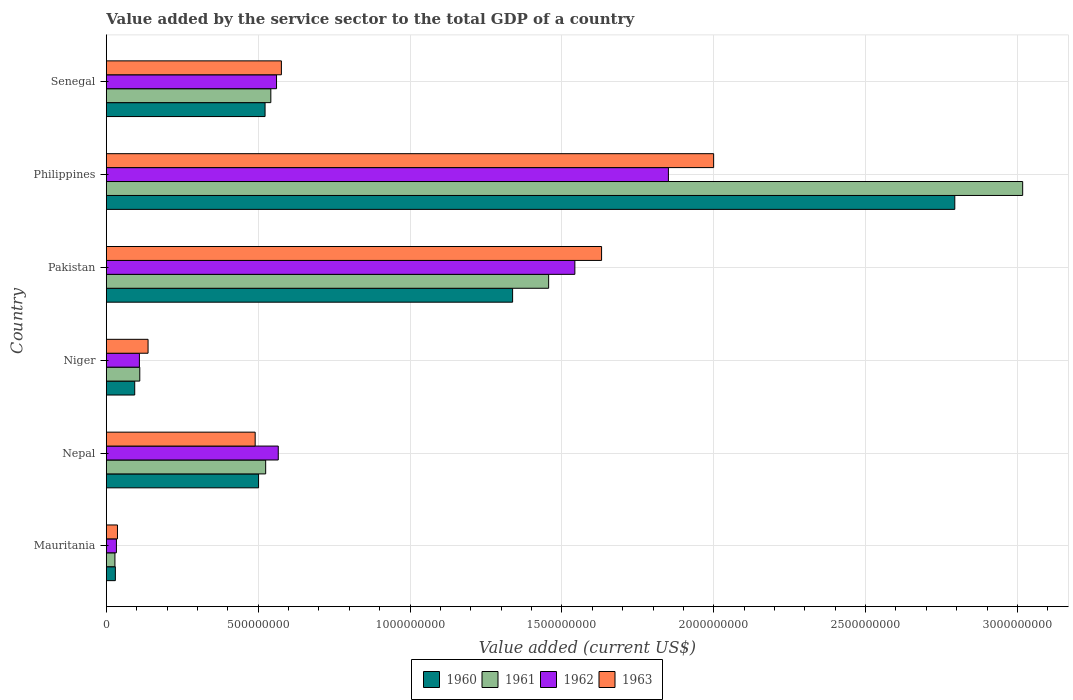How many groups of bars are there?
Provide a short and direct response. 6. Are the number of bars per tick equal to the number of legend labels?
Offer a very short reply. Yes. How many bars are there on the 2nd tick from the top?
Make the answer very short. 4. How many bars are there on the 4th tick from the bottom?
Your answer should be compact. 4. What is the value added by the service sector to the total GDP in 1960 in Mauritania?
Your response must be concise. 2.97e+07. Across all countries, what is the maximum value added by the service sector to the total GDP in 1962?
Keep it short and to the point. 1.85e+09. Across all countries, what is the minimum value added by the service sector to the total GDP in 1962?
Provide a succinct answer. 3.32e+07. In which country was the value added by the service sector to the total GDP in 1962 minimum?
Offer a terse response. Mauritania. What is the total value added by the service sector to the total GDP in 1960 in the graph?
Offer a terse response. 5.28e+09. What is the difference between the value added by the service sector to the total GDP in 1963 in Pakistan and that in Philippines?
Make the answer very short. -3.69e+08. What is the difference between the value added by the service sector to the total GDP in 1962 in Senegal and the value added by the service sector to the total GDP in 1960 in Philippines?
Provide a short and direct response. -2.23e+09. What is the average value added by the service sector to the total GDP in 1963 per country?
Make the answer very short. 8.12e+08. What is the difference between the value added by the service sector to the total GDP in 1960 and value added by the service sector to the total GDP in 1963 in Philippines?
Provide a short and direct response. 7.94e+08. In how many countries, is the value added by the service sector to the total GDP in 1960 greater than 1500000000 US$?
Ensure brevity in your answer.  1. What is the ratio of the value added by the service sector to the total GDP in 1963 in Niger to that in Pakistan?
Provide a succinct answer. 0.08. Is the value added by the service sector to the total GDP in 1963 in Mauritania less than that in Nepal?
Make the answer very short. Yes. What is the difference between the highest and the second highest value added by the service sector to the total GDP in 1960?
Provide a succinct answer. 1.46e+09. What is the difference between the highest and the lowest value added by the service sector to the total GDP in 1960?
Ensure brevity in your answer.  2.76e+09. In how many countries, is the value added by the service sector to the total GDP in 1963 greater than the average value added by the service sector to the total GDP in 1963 taken over all countries?
Keep it short and to the point. 2. Is it the case that in every country, the sum of the value added by the service sector to the total GDP in 1961 and value added by the service sector to the total GDP in 1960 is greater than the sum of value added by the service sector to the total GDP in 1963 and value added by the service sector to the total GDP in 1962?
Make the answer very short. No. What does the 2nd bar from the bottom in Pakistan represents?
Offer a terse response. 1961. How many countries are there in the graph?
Keep it short and to the point. 6. Are the values on the major ticks of X-axis written in scientific E-notation?
Ensure brevity in your answer.  No. Does the graph contain any zero values?
Offer a terse response. No. Does the graph contain grids?
Provide a short and direct response. Yes. How many legend labels are there?
Ensure brevity in your answer.  4. How are the legend labels stacked?
Your answer should be very brief. Horizontal. What is the title of the graph?
Provide a succinct answer. Value added by the service sector to the total GDP of a country. What is the label or title of the X-axis?
Give a very brief answer. Value added (current US$). What is the Value added (current US$) of 1960 in Mauritania?
Your response must be concise. 2.97e+07. What is the Value added (current US$) of 1961 in Mauritania?
Your answer should be very brief. 2.83e+07. What is the Value added (current US$) of 1962 in Mauritania?
Provide a succinct answer. 3.32e+07. What is the Value added (current US$) of 1963 in Mauritania?
Give a very brief answer. 3.67e+07. What is the Value added (current US$) of 1960 in Nepal?
Provide a short and direct response. 5.01e+08. What is the Value added (current US$) in 1961 in Nepal?
Provide a succinct answer. 5.25e+08. What is the Value added (current US$) of 1962 in Nepal?
Your response must be concise. 5.66e+08. What is the Value added (current US$) of 1963 in Nepal?
Your answer should be very brief. 4.90e+08. What is the Value added (current US$) in 1960 in Niger?
Make the answer very short. 9.35e+07. What is the Value added (current US$) of 1961 in Niger?
Offer a terse response. 1.10e+08. What is the Value added (current US$) of 1962 in Niger?
Provide a short and direct response. 1.09e+08. What is the Value added (current US$) in 1963 in Niger?
Provide a succinct answer. 1.37e+08. What is the Value added (current US$) of 1960 in Pakistan?
Provide a succinct answer. 1.34e+09. What is the Value added (current US$) in 1961 in Pakistan?
Ensure brevity in your answer.  1.46e+09. What is the Value added (current US$) of 1962 in Pakistan?
Your answer should be very brief. 1.54e+09. What is the Value added (current US$) in 1963 in Pakistan?
Give a very brief answer. 1.63e+09. What is the Value added (current US$) of 1960 in Philippines?
Ensure brevity in your answer.  2.79e+09. What is the Value added (current US$) in 1961 in Philippines?
Your answer should be compact. 3.02e+09. What is the Value added (current US$) of 1962 in Philippines?
Your answer should be compact. 1.85e+09. What is the Value added (current US$) in 1963 in Philippines?
Offer a very short reply. 2.00e+09. What is the Value added (current US$) of 1960 in Senegal?
Your answer should be compact. 5.23e+08. What is the Value added (current US$) of 1961 in Senegal?
Provide a short and direct response. 5.42e+08. What is the Value added (current US$) of 1962 in Senegal?
Your response must be concise. 5.60e+08. What is the Value added (current US$) in 1963 in Senegal?
Your response must be concise. 5.76e+08. Across all countries, what is the maximum Value added (current US$) in 1960?
Your answer should be compact. 2.79e+09. Across all countries, what is the maximum Value added (current US$) in 1961?
Your answer should be very brief. 3.02e+09. Across all countries, what is the maximum Value added (current US$) of 1962?
Provide a succinct answer. 1.85e+09. Across all countries, what is the maximum Value added (current US$) of 1963?
Provide a short and direct response. 2.00e+09. Across all countries, what is the minimum Value added (current US$) in 1960?
Your answer should be very brief. 2.97e+07. Across all countries, what is the minimum Value added (current US$) of 1961?
Provide a short and direct response. 2.83e+07. Across all countries, what is the minimum Value added (current US$) of 1962?
Your answer should be very brief. 3.32e+07. Across all countries, what is the minimum Value added (current US$) in 1963?
Make the answer very short. 3.67e+07. What is the total Value added (current US$) of 1960 in the graph?
Give a very brief answer. 5.28e+09. What is the total Value added (current US$) of 1961 in the graph?
Keep it short and to the point. 5.68e+09. What is the total Value added (current US$) of 1962 in the graph?
Ensure brevity in your answer.  4.66e+09. What is the total Value added (current US$) of 1963 in the graph?
Provide a succinct answer. 4.87e+09. What is the difference between the Value added (current US$) of 1960 in Mauritania and that in Nepal?
Your answer should be very brief. -4.72e+08. What is the difference between the Value added (current US$) in 1961 in Mauritania and that in Nepal?
Your response must be concise. -4.96e+08. What is the difference between the Value added (current US$) in 1962 in Mauritania and that in Nepal?
Your answer should be compact. -5.33e+08. What is the difference between the Value added (current US$) in 1963 in Mauritania and that in Nepal?
Ensure brevity in your answer.  -4.53e+08. What is the difference between the Value added (current US$) of 1960 in Mauritania and that in Niger?
Provide a succinct answer. -6.37e+07. What is the difference between the Value added (current US$) of 1961 in Mauritania and that in Niger?
Your answer should be very brief. -8.18e+07. What is the difference between the Value added (current US$) in 1962 in Mauritania and that in Niger?
Your answer should be compact. -7.57e+07. What is the difference between the Value added (current US$) in 1963 in Mauritania and that in Niger?
Your answer should be very brief. -1.01e+08. What is the difference between the Value added (current US$) in 1960 in Mauritania and that in Pakistan?
Give a very brief answer. -1.31e+09. What is the difference between the Value added (current US$) in 1961 in Mauritania and that in Pakistan?
Your answer should be very brief. -1.43e+09. What is the difference between the Value added (current US$) in 1962 in Mauritania and that in Pakistan?
Ensure brevity in your answer.  -1.51e+09. What is the difference between the Value added (current US$) of 1963 in Mauritania and that in Pakistan?
Your answer should be compact. -1.59e+09. What is the difference between the Value added (current US$) of 1960 in Mauritania and that in Philippines?
Make the answer very short. -2.76e+09. What is the difference between the Value added (current US$) of 1961 in Mauritania and that in Philippines?
Your answer should be very brief. -2.99e+09. What is the difference between the Value added (current US$) of 1962 in Mauritania and that in Philippines?
Your answer should be very brief. -1.82e+09. What is the difference between the Value added (current US$) of 1963 in Mauritania and that in Philippines?
Offer a very short reply. -1.96e+09. What is the difference between the Value added (current US$) in 1960 in Mauritania and that in Senegal?
Ensure brevity in your answer.  -4.93e+08. What is the difference between the Value added (current US$) in 1961 in Mauritania and that in Senegal?
Ensure brevity in your answer.  -5.13e+08. What is the difference between the Value added (current US$) in 1962 in Mauritania and that in Senegal?
Offer a terse response. -5.27e+08. What is the difference between the Value added (current US$) in 1963 in Mauritania and that in Senegal?
Ensure brevity in your answer.  -5.40e+08. What is the difference between the Value added (current US$) of 1960 in Nepal and that in Niger?
Ensure brevity in your answer.  4.08e+08. What is the difference between the Value added (current US$) of 1961 in Nepal and that in Niger?
Offer a terse response. 4.14e+08. What is the difference between the Value added (current US$) of 1962 in Nepal and that in Niger?
Offer a terse response. 4.57e+08. What is the difference between the Value added (current US$) in 1963 in Nepal and that in Niger?
Keep it short and to the point. 3.53e+08. What is the difference between the Value added (current US$) of 1960 in Nepal and that in Pakistan?
Offer a terse response. -8.36e+08. What is the difference between the Value added (current US$) of 1961 in Nepal and that in Pakistan?
Provide a succinct answer. -9.32e+08. What is the difference between the Value added (current US$) of 1962 in Nepal and that in Pakistan?
Provide a succinct answer. -9.77e+08. What is the difference between the Value added (current US$) of 1963 in Nepal and that in Pakistan?
Offer a very short reply. -1.14e+09. What is the difference between the Value added (current US$) in 1960 in Nepal and that in Philippines?
Your answer should be very brief. -2.29e+09. What is the difference between the Value added (current US$) of 1961 in Nepal and that in Philippines?
Provide a short and direct response. -2.49e+09. What is the difference between the Value added (current US$) in 1962 in Nepal and that in Philippines?
Give a very brief answer. -1.28e+09. What is the difference between the Value added (current US$) in 1963 in Nepal and that in Philippines?
Give a very brief answer. -1.51e+09. What is the difference between the Value added (current US$) in 1960 in Nepal and that in Senegal?
Keep it short and to the point. -2.14e+07. What is the difference between the Value added (current US$) in 1961 in Nepal and that in Senegal?
Your answer should be compact. -1.70e+07. What is the difference between the Value added (current US$) of 1962 in Nepal and that in Senegal?
Give a very brief answer. 5.71e+06. What is the difference between the Value added (current US$) of 1963 in Nepal and that in Senegal?
Give a very brief answer. -8.63e+07. What is the difference between the Value added (current US$) of 1960 in Niger and that in Pakistan?
Ensure brevity in your answer.  -1.24e+09. What is the difference between the Value added (current US$) of 1961 in Niger and that in Pakistan?
Keep it short and to the point. -1.35e+09. What is the difference between the Value added (current US$) of 1962 in Niger and that in Pakistan?
Provide a short and direct response. -1.43e+09. What is the difference between the Value added (current US$) in 1963 in Niger and that in Pakistan?
Your answer should be very brief. -1.49e+09. What is the difference between the Value added (current US$) in 1960 in Niger and that in Philippines?
Ensure brevity in your answer.  -2.70e+09. What is the difference between the Value added (current US$) of 1961 in Niger and that in Philippines?
Ensure brevity in your answer.  -2.91e+09. What is the difference between the Value added (current US$) in 1962 in Niger and that in Philippines?
Give a very brief answer. -1.74e+09. What is the difference between the Value added (current US$) of 1963 in Niger and that in Philippines?
Provide a succinct answer. -1.86e+09. What is the difference between the Value added (current US$) of 1960 in Niger and that in Senegal?
Give a very brief answer. -4.29e+08. What is the difference between the Value added (current US$) of 1961 in Niger and that in Senegal?
Offer a terse response. -4.32e+08. What is the difference between the Value added (current US$) of 1962 in Niger and that in Senegal?
Ensure brevity in your answer.  -4.51e+08. What is the difference between the Value added (current US$) in 1963 in Niger and that in Senegal?
Offer a terse response. -4.39e+08. What is the difference between the Value added (current US$) in 1960 in Pakistan and that in Philippines?
Your response must be concise. -1.46e+09. What is the difference between the Value added (current US$) of 1961 in Pakistan and that in Philippines?
Your response must be concise. -1.56e+09. What is the difference between the Value added (current US$) of 1962 in Pakistan and that in Philippines?
Ensure brevity in your answer.  -3.08e+08. What is the difference between the Value added (current US$) of 1963 in Pakistan and that in Philippines?
Your answer should be compact. -3.69e+08. What is the difference between the Value added (current US$) in 1960 in Pakistan and that in Senegal?
Ensure brevity in your answer.  8.15e+08. What is the difference between the Value added (current US$) of 1961 in Pakistan and that in Senegal?
Make the answer very short. 9.15e+08. What is the difference between the Value added (current US$) of 1962 in Pakistan and that in Senegal?
Make the answer very short. 9.82e+08. What is the difference between the Value added (current US$) in 1963 in Pakistan and that in Senegal?
Your answer should be very brief. 1.05e+09. What is the difference between the Value added (current US$) of 1960 in Philippines and that in Senegal?
Provide a succinct answer. 2.27e+09. What is the difference between the Value added (current US$) of 1961 in Philippines and that in Senegal?
Give a very brief answer. 2.48e+09. What is the difference between the Value added (current US$) of 1962 in Philippines and that in Senegal?
Offer a very short reply. 1.29e+09. What is the difference between the Value added (current US$) in 1963 in Philippines and that in Senegal?
Provide a succinct answer. 1.42e+09. What is the difference between the Value added (current US$) of 1960 in Mauritania and the Value added (current US$) of 1961 in Nepal?
Give a very brief answer. -4.95e+08. What is the difference between the Value added (current US$) in 1960 in Mauritania and the Value added (current US$) in 1962 in Nepal?
Your answer should be compact. -5.36e+08. What is the difference between the Value added (current US$) in 1960 in Mauritania and the Value added (current US$) in 1963 in Nepal?
Provide a succinct answer. -4.60e+08. What is the difference between the Value added (current US$) of 1961 in Mauritania and the Value added (current US$) of 1962 in Nepal?
Provide a succinct answer. -5.38e+08. What is the difference between the Value added (current US$) in 1961 in Mauritania and the Value added (current US$) in 1963 in Nepal?
Your answer should be compact. -4.62e+08. What is the difference between the Value added (current US$) of 1962 in Mauritania and the Value added (current US$) of 1963 in Nepal?
Your response must be concise. -4.57e+08. What is the difference between the Value added (current US$) in 1960 in Mauritania and the Value added (current US$) in 1961 in Niger?
Ensure brevity in your answer.  -8.04e+07. What is the difference between the Value added (current US$) of 1960 in Mauritania and the Value added (current US$) of 1962 in Niger?
Provide a succinct answer. -7.92e+07. What is the difference between the Value added (current US$) in 1960 in Mauritania and the Value added (current US$) in 1963 in Niger?
Your answer should be compact. -1.08e+08. What is the difference between the Value added (current US$) of 1961 in Mauritania and the Value added (current US$) of 1962 in Niger?
Offer a very short reply. -8.06e+07. What is the difference between the Value added (current US$) in 1961 in Mauritania and the Value added (current US$) in 1963 in Niger?
Your response must be concise. -1.09e+08. What is the difference between the Value added (current US$) of 1962 in Mauritania and the Value added (current US$) of 1963 in Niger?
Your answer should be very brief. -1.04e+08. What is the difference between the Value added (current US$) in 1960 in Mauritania and the Value added (current US$) in 1961 in Pakistan?
Provide a succinct answer. -1.43e+09. What is the difference between the Value added (current US$) of 1960 in Mauritania and the Value added (current US$) of 1962 in Pakistan?
Ensure brevity in your answer.  -1.51e+09. What is the difference between the Value added (current US$) in 1960 in Mauritania and the Value added (current US$) in 1963 in Pakistan?
Offer a terse response. -1.60e+09. What is the difference between the Value added (current US$) in 1961 in Mauritania and the Value added (current US$) in 1962 in Pakistan?
Make the answer very short. -1.51e+09. What is the difference between the Value added (current US$) in 1961 in Mauritania and the Value added (current US$) in 1963 in Pakistan?
Offer a very short reply. -1.60e+09. What is the difference between the Value added (current US$) in 1962 in Mauritania and the Value added (current US$) in 1963 in Pakistan?
Provide a short and direct response. -1.60e+09. What is the difference between the Value added (current US$) in 1960 in Mauritania and the Value added (current US$) in 1961 in Philippines?
Your answer should be compact. -2.99e+09. What is the difference between the Value added (current US$) in 1960 in Mauritania and the Value added (current US$) in 1962 in Philippines?
Provide a succinct answer. -1.82e+09. What is the difference between the Value added (current US$) of 1960 in Mauritania and the Value added (current US$) of 1963 in Philippines?
Keep it short and to the point. -1.97e+09. What is the difference between the Value added (current US$) in 1961 in Mauritania and the Value added (current US$) in 1962 in Philippines?
Provide a succinct answer. -1.82e+09. What is the difference between the Value added (current US$) of 1961 in Mauritania and the Value added (current US$) of 1963 in Philippines?
Make the answer very short. -1.97e+09. What is the difference between the Value added (current US$) in 1962 in Mauritania and the Value added (current US$) in 1963 in Philippines?
Your response must be concise. -1.97e+09. What is the difference between the Value added (current US$) in 1960 in Mauritania and the Value added (current US$) in 1961 in Senegal?
Ensure brevity in your answer.  -5.12e+08. What is the difference between the Value added (current US$) of 1960 in Mauritania and the Value added (current US$) of 1962 in Senegal?
Your response must be concise. -5.31e+08. What is the difference between the Value added (current US$) of 1960 in Mauritania and the Value added (current US$) of 1963 in Senegal?
Your answer should be compact. -5.47e+08. What is the difference between the Value added (current US$) in 1961 in Mauritania and the Value added (current US$) in 1962 in Senegal?
Your response must be concise. -5.32e+08. What is the difference between the Value added (current US$) of 1961 in Mauritania and the Value added (current US$) of 1963 in Senegal?
Ensure brevity in your answer.  -5.48e+08. What is the difference between the Value added (current US$) in 1962 in Mauritania and the Value added (current US$) in 1963 in Senegal?
Give a very brief answer. -5.43e+08. What is the difference between the Value added (current US$) of 1960 in Nepal and the Value added (current US$) of 1961 in Niger?
Keep it short and to the point. 3.91e+08. What is the difference between the Value added (current US$) in 1960 in Nepal and the Value added (current US$) in 1962 in Niger?
Make the answer very short. 3.92e+08. What is the difference between the Value added (current US$) in 1960 in Nepal and the Value added (current US$) in 1963 in Niger?
Provide a short and direct response. 3.64e+08. What is the difference between the Value added (current US$) of 1961 in Nepal and the Value added (current US$) of 1962 in Niger?
Your response must be concise. 4.16e+08. What is the difference between the Value added (current US$) in 1961 in Nepal and the Value added (current US$) in 1963 in Niger?
Give a very brief answer. 3.87e+08. What is the difference between the Value added (current US$) in 1962 in Nepal and the Value added (current US$) in 1963 in Niger?
Your response must be concise. 4.29e+08. What is the difference between the Value added (current US$) of 1960 in Nepal and the Value added (current US$) of 1961 in Pakistan?
Provide a succinct answer. -9.55e+08. What is the difference between the Value added (current US$) in 1960 in Nepal and the Value added (current US$) in 1962 in Pakistan?
Make the answer very short. -1.04e+09. What is the difference between the Value added (current US$) in 1960 in Nepal and the Value added (current US$) in 1963 in Pakistan?
Provide a short and direct response. -1.13e+09. What is the difference between the Value added (current US$) in 1961 in Nepal and the Value added (current US$) in 1962 in Pakistan?
Your response must be concise. -1.02e+09. What is the difference between the Value added (current US$) of 1961 in Nepal and the Value added (current US$) of 1963 in Pakistan?
Provide a short and direct response. -1.11e+09. What is the difference between the Value added (current US$) in 1962 in Nepal and the Value added (current US$) in 1963 in Pakistan?
Give a very brief answer. -1.06e+09. What is the difference between the Value added (current US$) of 1960 in Nepal and the Value added (current US$) of 1961 in Philippines?
Provide a short and direct response. -2.52e+09. What is the difference between the Value added (current US$) of 1960 in Nepal and the Value added (current US$) of 1962 in Philippines?
Give a very brief answer. -1.35e+09. What is the difference between the Value added (current US$) in 1960 in Nepal and the Value added (current US$) in 1963 in Philippines?
Ensure brevity in your answer.  -1.50e+09. What is the difference between the Value added (current US$) of 1961 in Nepal and the Value added (current US$) of 1962 in Philippines?
Your answer should be compact. -1.33e+09. What is the difference between the Value added (current US$) in 1961 in Nepal and the Value added (current US$) in 1963 in Philippines?
Your answer should be very brief. -1.47e+09. What is the difference between the Value added (current US$) in 1962 in Nepal and the Value added (current US$) in 1963 in Philippines?
Provide a short and direct response. -1.43e+09. What is the difference between the Value added (current US$) of 1960 in Nepal and the Value added (current US$) of 1961 in Senegal?
Provide a succinct answer. -4.04e+07. What is the difference between the Value added (current US$) in 1960 in Nepal and the Value added (current US$) in 1962 in Senegal?
Give a very brief answer. -5.91e+07. What is the difference between the Value added (current US$) of 1960 in Nepal and the Value added (current US$) of 1963 in Senegal?
Your answer should be compact. -7.51e+07. What is the difference between the Value added (current US$) of 1961 in Nepal and the Value added (current US$) of 1962 in Senegal?
Your answer should be compact. -3.58e+07. What is the difference between the Value added (current US$) in 1961 in Nepal and the Value added (current US$) in 1963 in Senegal?
Offer a terse response. -5.18e+07. What is the difference between the Value added (current US$) in 1962 in Nepal and the Value added (current US$) in 1963 in Senegal?
Keep it short and to the point. -1.03e+07. What is the difference between the Value added (current US$) of 1960 in Niger and the Value added (current US$) of 1961 in Pakistan?
Make the answer very short. -1.36e+09. What is the difference between the Value added (current US$) of 1960 in Niger and the Value added (current US$) of 1962 in Pakistan?
Provide a short and direct response. -1.45e+09. What is the difference between the Value added (current US$) in 1960 in Niger and the Value added (current US$) in 1963 in Pakistan?
Provide a succinct answer. -1.54e+09. What is the difference between the Value added (current US$) of 1961 in Niger and the Value added (current US$) of 1962 in Pakistan?
Your response must be concise. -1.43e+09. What is the difference between the Value added (current US$) in 1961 in Niger and the Value added (current US$) in 1963 in Pakistan?
Provide a succinct answer. -1.52e+09. What is the difference between the Value added (current US$) in 1962 in Niger and the Value added (current US$) in 1963 in Pakistan?
Your answer should be compact. -1.52e+09. What is the difference between the Value added (current US$) of 1960 in Niger and the Value added (current US$) of 1961 in Philippines?
Provide a short and direct response. -2.92e+09. What is the difference between the Value added (current US$) of 1960 in Niger and the Value added (current US$) of 1962 in Philippines?
Keep it short and to the point. -1.76e+09. What is the difference between the Value added (current US$) of 1960 in Niger and the Value added (current US$) of 1963 in Philippines?
Give a very brief answer. -1.91e+09. What is the difference between the Value added (current US$) in 1961 in Niger and the Value added (current US$) in 1962 in Philippines?
Your answer should be very brief. -1.74e+09. What is the difference between the Value added (current US$) of 1961 in Niger and the Value added (current US$) of 1963 in Philippines?
Provide a short and direct response. -1.89e+09. What is the difference between the Value added (current US$) in 1962 in Niger and the Value added (current US$) in 1963 in Philippines?
Your response must be concise. -1.89e+09. What is the difference between the Value added (current US$) in 1960 in Niger and the Value added (current US$) in 1961 in Senegal?
Offer a very short reply. -4.48e+08. What is the difference between the Value added (current US$) of 1960 in Niger and the Value added (current US$) of 1962 in Senegal?
Ensure brevity in your answer.  -4.67e+08. What is the difference between the Value added (current US$) of 1960 in Niger and the Value added (current US$) of 1963 in Senegal?
Offer a very short reply. -4.83e+08. What is the difference between the Value added (current US$) in 1961 in Niger and the Value added (current US$) in 1962 in Senegal?
Offer a very short reply. -4.50e+08. What is the difference between the Value added (current US$) of 1961 in Niger and the Value added (current US$) of 1963 in Senegal?
Give a very brief answer. -4.66e+08. What is the difference between the Value added (current US$) in 1962 in Niger and the Value added (current US$) in 1963 in Senegal?
Provide a short and direct response. -4.67e+08. What is the difference between the Value added (current US$) in 1960 in Pakistan and the Value added (current US$) in 1961 in Philippines?
Ensure brevity in your answer.  -1.68e+09. What is the difference between the Value added (current US$) of 1960 in Pakistan and the Value added (current US$) of 1962 in Philippines?
Give a very brief answer. -5.13e+08. What is the difference between the Value added (current US$) of 1960 in Pakistan and the Value added (current US$) of 1963 in Philippines?
Offer a very short reply. -6.62e+08. What is the difference between the Value added (current US$) in 1961 in Pakistan and the Value added (current US$) in 1962 in Philippines?
Give a very brief answer. -3.94e+08. What is the difference between the Value added (current US$) in 1961 in Pakistan and the Value added (current US$) in 1963 in Philippines?
Make the answer very short. -5.43e+08. What is the difference between the Value added (current US$) in 1962 in Pakistan and the Value added (current US$) in 1963 in Philippines?
Give a very brief answer. -4.57e+08. What is the difference between the Value added (current US$) in 1960 in Pakistan and the Value added (current US$) in 1961 in Senegal?
Offer a terse response. 7.96e+08. What is the difference between the Value added (current US$) of 1960 in Pakistan and the Value added (current US$) of 1962 in Senegal?
Provide a succinct answer. 7.77e+08. What is the difference between the Value added (current US$) of 1960 in Pakistan and the Value added (current US$) of 1963 in Senegal?
Make the answer very short. 7.61e+08. What is the difference between the Value added (current US$) of 1961 in Pakistan and the Value added (current US$) of 1962 in Senegal?
Provide a short and direct response. 8.96e+08. What is the difference between the Value added (current US$) of 1961 in Pakistan and the Value added (current US$) of 1963 in Senegal?
Your response must be concise. 8.80e+08. What is the difference between the Value added (current US$) of 1962 in Pakistan and the Value added (current US$) of 1963 in Senegal?
Provide a succinct answer. 9.66e+08. What is the difference between the Value added (current US$) of 1960 in Philippines and the Value added (current US$) of 1961 in Senegal?
Offer a terse response. 2.25e+09. What is the difference between the Value added (current US$) of 1960 in Philippines and the Value added (current US$) of 1962 in Senegal?
Ensure brevity in your answer.  2.23e+09. What is the difference between the Value added (current US$) in 1960 in Philippines and the Value added (current US$) in 1963 in Senegal?
Your response must be concise. 2.22e+09. What is the difference between the Value added (current US$) of 1961 in Philippines and the Value added (current US$) of 1962 in Senegal?
Offer a terse response. 2.46e+09. What is the difference between the Value added (current US$) of 1961 in Philippines and the Value added (current US$) of 1963 in Senegal?
Offer a terse response. 2.44e+09. What is the difference between the Value added (current US$) of 1962 in Philippines and the Value added (current US$) of 1963 in Senegal?
Offer a very short reply. 1.27e+09. What is the average Value added (current US$) of 1960 per country?
Provide a succinct answer. 8.80e+08. What is the average Value added (current US$) of 1961 per country?
Make the answer very short. 9.46e+08. What is the average Value added (current US$) in 1962 per country?
Provide a succinct answer. 7.77e+08. What is the average Value added (current US$) in 1963 per country?
Ensure brevity in your answer.  8.12e+08. What is the difference between the Value added (current US$) of 1960 and Value added (current US$) of 1961 in Mauritania?
Your answer should be compact. 1.42e+06. What is the difference between the Value added (current US$) in 1960 and Value added (current US$) in 1962 in Mauritania?
Ensure brevity in your answer.  -3.51e+06. What is the difference between the Value added (current US$) of 1960 and Value added (current US$) of 1963 in Mauritania?
Offer a terse response. -6.94e+06. What is the difference between the Value added (current US$) in 1961 and Value added (current US$) in 1962 in Mauritania?
Your answer should be very brief. -4.93e+06. What is the difference between the Value added (current US$) in 1961 and Value added (current US$) in 1963 in Mauritania?
Your answer should be very brief. -8.35e+06. What is the difference between the Value added (current US$) of 1962 and Value added (current US$) of 1963 in Mauritania?
Your answer should be very brief. -3.42e+06. What is the difference between the Value added (current US$) of 1960 and Value added (current US$) of 1961 in Nepal?
Your answer should be compact. -2.34e+07. What is the difference between the Value added (current US$) of 1960 and Value added (current US$) of 1962 in Nepal?
Give a very brief answer. -6.48e+07. What is the difference between the Value added (current US$) in 1960 and Value added (current US$) in 1963 in Nepal?
Ensure brevity in your answer.  1.12e+07. What is the difference between the Value added (current US$) of 1961 and Value added (current US$) of 1962 in Nepal?
Offer a very short reply. -4.15e+07. What is the difference between the Value added (current US$) in 1961 and Value added (current US$) in 1963 in Nepal?
Your answer should be compact. 3.46e+07. What is the difference between the Value added (current US$) of 1962 and Value added (current US$) of 1963 in Nepal?
Offer a very short reply. 7.60e+07. What is the difference between the Value added (current US$) in 1960 and Value added (current US$) in 1961 in Niger?
Ensure brevity in your answer.  -1.67e+07. What is the difference between the Value added (current US$) in 1960 and Value added (current US$) in 1962 in Niger?
Your response must be concise. -1.55e+07. What is the difference between the Value added (current US$) in 1960 and Value added (current US$) in 1963 in Niger?
Your answer should be compact. -4.40e+07. What is the difference between the Value added (current US$) of 1961 and Value added (current US$) of 1962 in Niger?
Offer a terse response. 1.20e+06. What is the difference between the Value added (current US$) in 1961 and Value added (current US$) in 1963 in Niger?
Provide a succinct answer. -2.73e+07. What is the difference between the Value added (current US$) of 1962 and Value added (current US$) of 1963 in Niger?
Keep it short and to the point. -2.85e+07. What is the difference between the Value added (current US$) of 1960 and Value added (current US$) of 1961 in Pakistan?
Your answer should be compact. -1.19e+08. What is the difference between the Value added (current US$) of 1960 and Value added (current US$) of 1962 in Pakistan?
Keep it short and to the point. -2.05e+08. What is the difference between the Value added (current US$) of 1960 and Value added (current US$) of 1963 in Pakistan?
Your answer should be very brief. -2.93e+08. What is the difference between the Value added (current US$) in 1961 and Value added (current US$) in 1962 in Pakistan?
Offer a very short reply. -8.63e+07. What is the difference between the Value added (current US$) of 1961 and Value added (current US$) of 1963 in Pakistan?
Ensure brevity in your answer.  -1.74e+08. What is the difference between the Value added (current US$) of 1962 and Value added (current US$) of 1963 in Pakistan?
Your response must be concise. -8.80e+07. What is the difference between the Value added (current US$) in 1960 and Value added (current US$) in 1961 in Philippines?
Ensure brevity in your answer.  -2.24e+08. What is the difference between the Value added (current US$) of 1960 and Value added (current US$) of 1962 in Philippines?
Ensure brevity in your answer.  9.43e+08. What is the difference between the Value added (current US$) in 1960 and Value added (current US$) in 1963 in Philippines?
Your response must be concise. 7.94e+08. What is the difference between the Value added (current US$) in 1961 and Value added (current US$) in 1962 in Philippines?
Make the answer very short. 1.17e+09. What is the difference between the Value added (current US$) of 1961 and Value added (current US$) of 1963 in Philippines?
Keep it short and to the point. 1.02e+09. What is the difference between the Value added (current US$) of 1962 and Value added (current US$) of 1963 in Philippines?
Provide a succinct answer. -1.49e+08. What is the difference between the Value added (current US$) of 1960 and Value added (current US$) of 1961 in Senegal?
Your answer should be very brief. -1.90e+07. What is the difference between the Value added (current US$) in 1960 and Value added (current US$) in 1962 in Senegal?
Your answer should be very brief. -3.77e+07. What is the difference between the Value added (current US$) of 1960 and Value added (current US$) of 1963 in Senegal?
Offer a terse response. -5.38e+07. What is the difference between the Value added (current US$) of 1961 and Value added (current US$) of 1962 in Senegal?
Make the answer very short. -1.87e+07. What is the difference between the Value added (current US$) in 1961 and Value added (current US$) in 1963 in Senegal?
Your answer should be compact. -3.48e+07. What is the difference between the Value added (current US$) of 1962 and Value added (current US$) of 1963 in Senegal?
Provide a short and direct response. -1.60e+07. What is the ratio of the Value added (current US$) of 1960 in Mauritania to that in Nepal?
Your answer should be compact. 0.06. What is the ratio of the Value added (current US$) of 1961 in Mauritania to that in Nepal?
Make the answer very short. 0.05. What is the ratio of the Value added (current US$) in 1962 in Mauritania to that in Nepal?
Provide a short and direct response. 0.06. What is the ratio of the Value added (current US$) in 1963 in Mauritania to that in Nepal?
Offer a very short reply. 0.07. What is the ratio of the Value added (current US$) in 1960 in Mauritania to that in Niger?
Give a very brief answer. 0.32. What is the ratio of the Value added (current US$) in 1961 in Mauritania to that in Niger?
Give a very brief answer. 0.26. What is the ratio of the Value added (current US$) of 1962 in Mauritania to that in Niger?
Offer a terse response. 0.31. What is the ratio of the Value added (current US$) in 1963 in Mauritania to that in Niger?
Keep it short and to the point. 0.27. What is the ratio of the Value added (current US$) in 1960 in Mauritania to that in Pakistan?
Offer a very short reply. 0.02. What is the ratio of the Value added (current US$) in 1961 in Mauritania to that in Pakistan?
Provide a succinct answer. 0.02. What is the ratio of the Value added (current US$) of 1962 in Mauritania to that in Pakistan?
Your answer should be very brief. 0.02. What is the ratio of the Value added (current US$) in 1963 in Mauritania to that in Pakistan?
Give a very brief answer. 0.02. What is the ratio of the Value added (current US$) in 1960 in Mauritania to that in Philippines?
Give a very brief answer. 0.01. What is the ratio of the Value added (current US$) in 1961 in Mauritania to that in Philippines?
Your answer should be compact. 0.01. What is the ratio of the Value added (current US$) in 1962 in Mauritania to that in Philippines?
Give a very brief answer. 0.02. What is the ratio of the Value added (current US$) of 1963 in Mauritania to that in Philippines?
Your answer should be compact. 0.02. What is the ratio of the Value added (current US$) of 1960 in Mauritania to that in Senegal?
Offer a very short reply. 0.06. What is the ratio of the Value added (current US$) in 1961 in Mauritania to that in Senegal?
Your answer should be compact. 0.05. What is the ratio of the Value added (current US$) of 1962 in Mauritania to that in Senegal?
Keep it short and to the point. 0.06. What is the ratio of the Value added (current US$) of 1963 in Mauritania to that in Senegal?
Make the answer very short. 0.06. What is the ratio of the Value added (current US$) in 1960 in Nepal to that in Niger?
Your answer should be very brief. 5.36. What is the ratio of the Value added (current US$) of 1961 in Nepal to that in Niger?
Your answer should be compact. 4.76. What is the ratio of the Value added (current US$) in 1962 in Nepal to that in Niger?
Provide a succinct answer. 5.2. What is the ratio of the Value added (current US$) of 1963 in Nepal to that in Niger?
Give a very brief answer. 3.57. What is the ratio of the Value added (current US$) of 1960 in Nepal to that in Pakistan?
Your answer should be very brief. 0.37. What is the ratio of the Value added (current US$) in 1961 in Nepal to that in Pakistan?
Give a very brief answer. 0.36. What is the ratio of the Value added (current US$) of 1962 in Nepal to that in Pakistan?
Offer a very short reply. 0.37. What is the ratio of the Value added (current US$) in 1963 in Nepal to that in Pakistan?
Your response must be concise. 0.3. What is the ratio of the Value added (current US$) in 1960 in Nepal to that in Philippines?
Offer a terse response. 0.18. What is the ratio of the Value added (current US$) in 1961 in Nepal to that in Philippines?
Your answer should be compact. 0.17. What is the ratio of the Value added (current US$) in 1962 in Nepal to that in Philippines?
Ensure brevity in your answer.  0.31. What is the ratio of the Value added (current US$) of 1963 in Nepal to that in Philippines?
Make the answer very short. 0.25. What is the ratio of the Value added (current US$) in 1960 in Nepal to that in Senegal?
Give a very brief answer. 0.96. What is the ratio of the Value added (current US$) in 1961 in Nepal to that in Senegal?
Ensure brevity in your answer.  0.97. What is the ratio of the Value added (current US$) in 1962 in Nepal to that in Senegal?
Ensure brevity in your answer.  1.01. What is the ratio of the Value added (current US$) in 1963 in Nepal to that in Senegal?
Provide a succinct answer. 0.85. What is the ratio of the Value added (current US$) of 1960 in Niger to that in Pakistan?
Ensure brevity in your answer.  0.07. What is the ratio of the Value added (current US$) in 1961 in Niger to that in Pakistan?
Give a very brief answer. 0.08. What is the ratio of the Value added (current US$) of 1962 in Niger to that in Pakistan?
Your answer should be compact. 0.07. What is the ratio of the Value added (current US$) in 1963 in Niger to that in Pakistan?
Your answer should be compact. 0.08. What is the ratio of the Value added (current US$) in 1960 in Niger to that in Philippines?
Offer a terse response. 0.03. What is the ratio of the Value added (current US$) of 1961 in Niger to that in Philippines?
Provide a succinct answer. 0.04. What is the ratio of the Value added (current US$) of 1962 in Niger to that in Philippines?
Make the answer very short. 0.06. What is the ratio of the Value added (current US$) in 1963 in Niger to that in Philippines?
Your response must be concise. 0.07. What is the ratio of the Value added (current US$) of 1960 in Niger to that in Senegal?
Your response must be concise. 0.18. What is the ratio of the Value added (current US$) of 1961 in Niger to that in Senegal?
Provide a succinct answer. 0.2. What is the ratio of the Value added (current US$) of 1962 in Niger to that in Senegal?
Your response must be concise. 0.19. What is the ratio of the Value added (current US$) of 1963 in Niger to that in Senegal?
Your answer should be very brief. 0.24. What is the ratio of the Value added (current US$) in 1960 in Pakistan to that in Philippines?
Ensure brevity in your answer.  0.48. What is the ratio of the Value added (current US$) of 1961 in Pakistan to that in Philippines?
Keep it short and to the point. 0.48. What is the ratio of the Value added (current US$) of 1962 in Pakistan to that in Philippines?
Ensure brevity in your answer.  0.83. What is the ratio of the Value added (current US$) in 1963 in Pakistan to that in Philippines?
Offer a very short reply. 0.82. What is the ratio of the Value added (current US$) in 1960 in Pakistan to that in Senegal?
Ensure brevity in your answer.  2.56. What is the ratio of the Value added (current US$) of 1961 in Pakistan to that in Senegal?
Offer a terse response. 2.69. What is the ratio of the Value added (current US$) of 1962 in Pakistan to that in Senegal?
Make the answer very short. 2.75. What is the ratio of the Value added (current US$) in 1963 in Pakistan to that in Senegal?
Ensure brevity in your answer.  2.83. What is the ratio of the Value added (current US$) of 1960 in Philippines to that in Senegal?
Make the answer very short. 5.35. What is the ratio of the Value added (current US$) of 1961 in Philippines to that in Senegal?
Offer a terse response. 5.57. What is the ratio of the Value added (current US$) in 1962 in Philippines to that in Senegal?
Ensure brevity in your answer.  3.3. What is the ratio of the Value added (current US$) of 1963 in Philippines to that in Senegal?
Give a very brief answer. 3.47. What is the difference between the highest and the second highest Value added (current US$) of 1960?
Offer a very short reply. 1.46e+09. What is the difference between the highest and the second highest Value added (current US$) of 1961?
Offer a terse response. 1.56e+09. What is the difference between the highest and the second highest Value added (current US$) in 1962?
Give a very brief answer. 3.08e+08. What is the difference between the highest and the second highest Value added (current US$) in 1963?
Offer a terse response. 3.69e+08. What is the difference between the highest and the lowest Value added (current US$) in 1960?
Your answer should be compact. 2.76e+09. What is the difference between the highest and the lowest Value added (current US$) in 1961?
Your response must be concise. 2.99e+09. What is the difference between the highest and the lowest Value added (current US$) in 1962?
Offer a very short reply. 1.82e+09. What is the difference between the highest and the lowest Value added (current US$) in 1963?
Your answer should be very brief. 1.96e+09. 